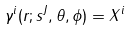Convert formula to latex. <formula><loc_0><loc_0><loc_500><loc_500>\gamma ^ { i } ( r ; s ^ { J } , \theta , \phi ) = X ^ { i }</formula> 